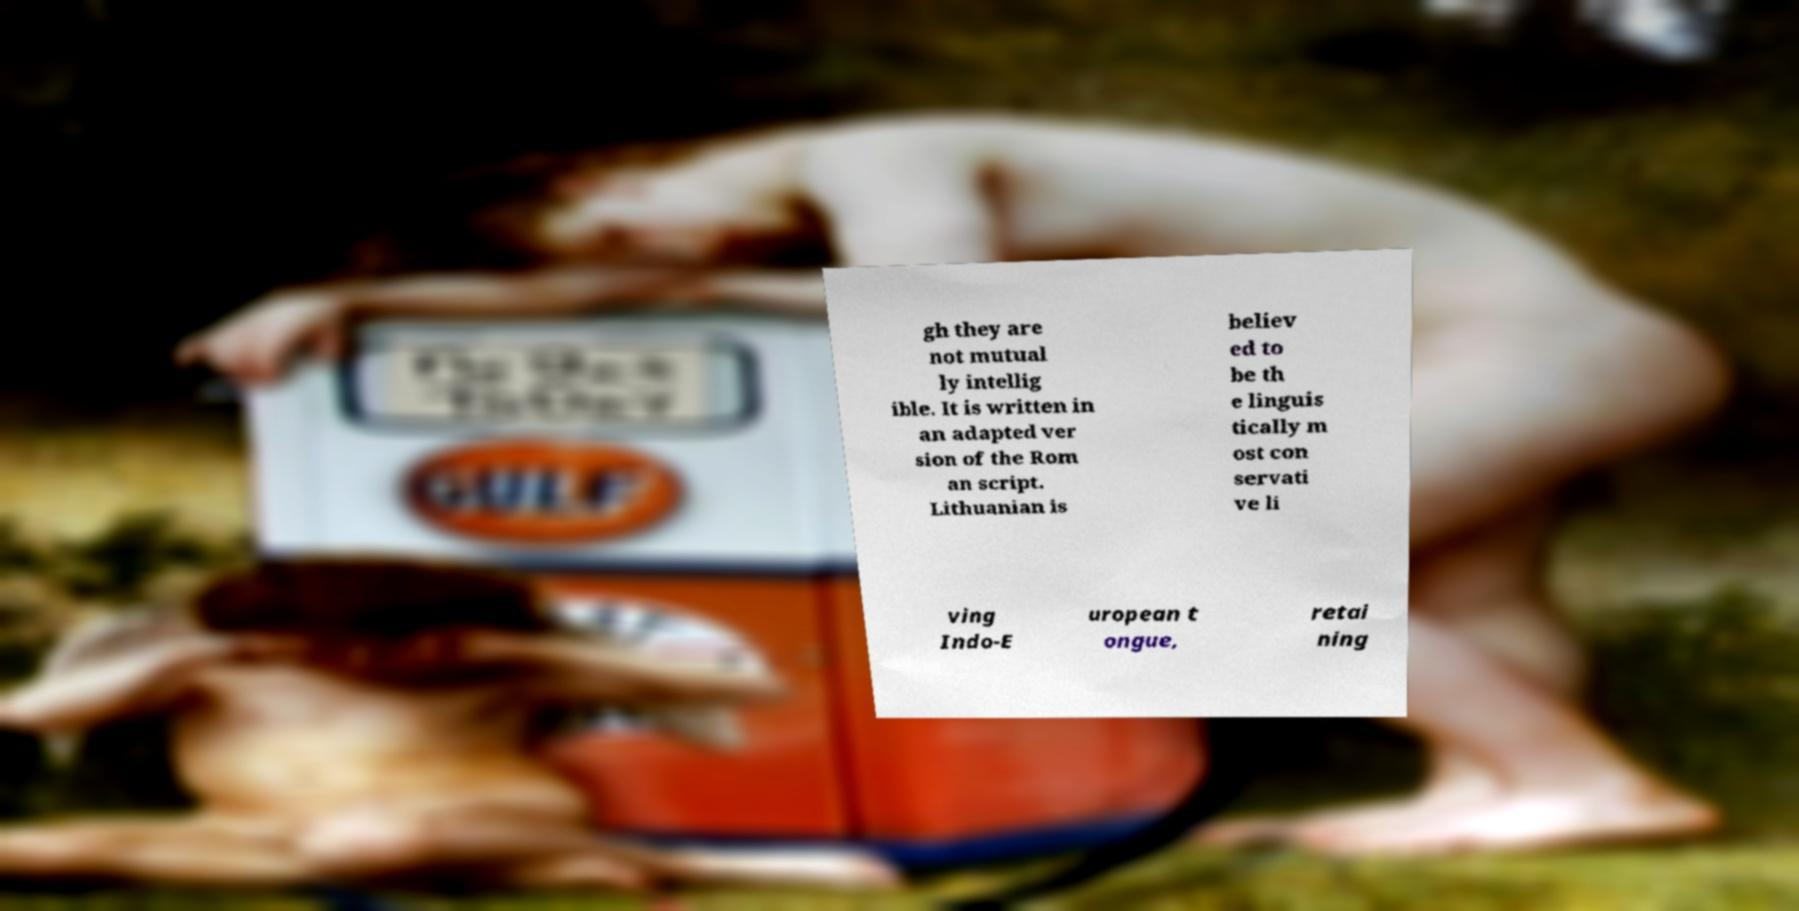Please identify and transcribe the text found in this image. gh they are not mutual ly intellig ible. It is written in an adapted ver sion of the Rom an script. Lithuanian is believ ed to be th e linguis tically m ost con servati ve li ving Indo-E uropean t ongue, retai ning 